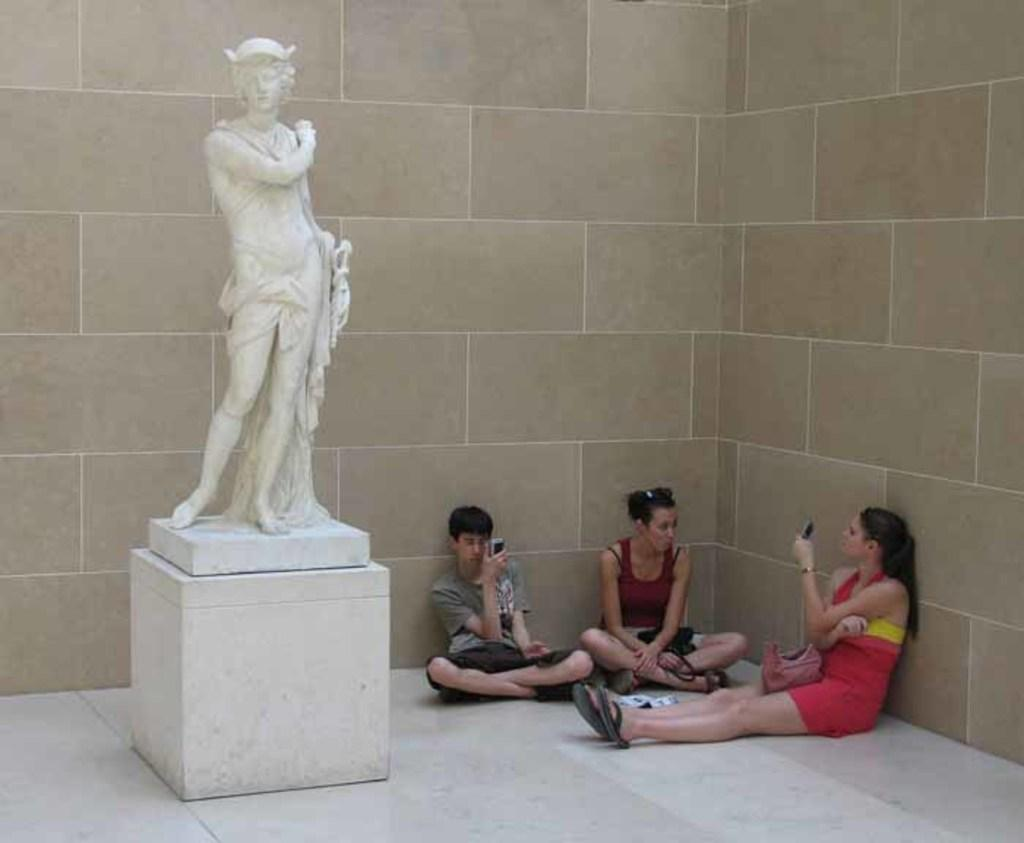How many people are sitting on the floor in the image? There are three persons sitting on the floor in the image. What else can be seen in the image besides the people sitting on the floor? There is a statue in the image. What is visible in the background of the image? There is a wall in the background of the image. What type of chicken is being used as a prop in the image? There is no chicken present in the image; it features three persons sitting on the floor and a statue. How many nails are visible in the image? There is no mention of nails in the provided facts, and therefore we cannot determine if any are visible in the image. 